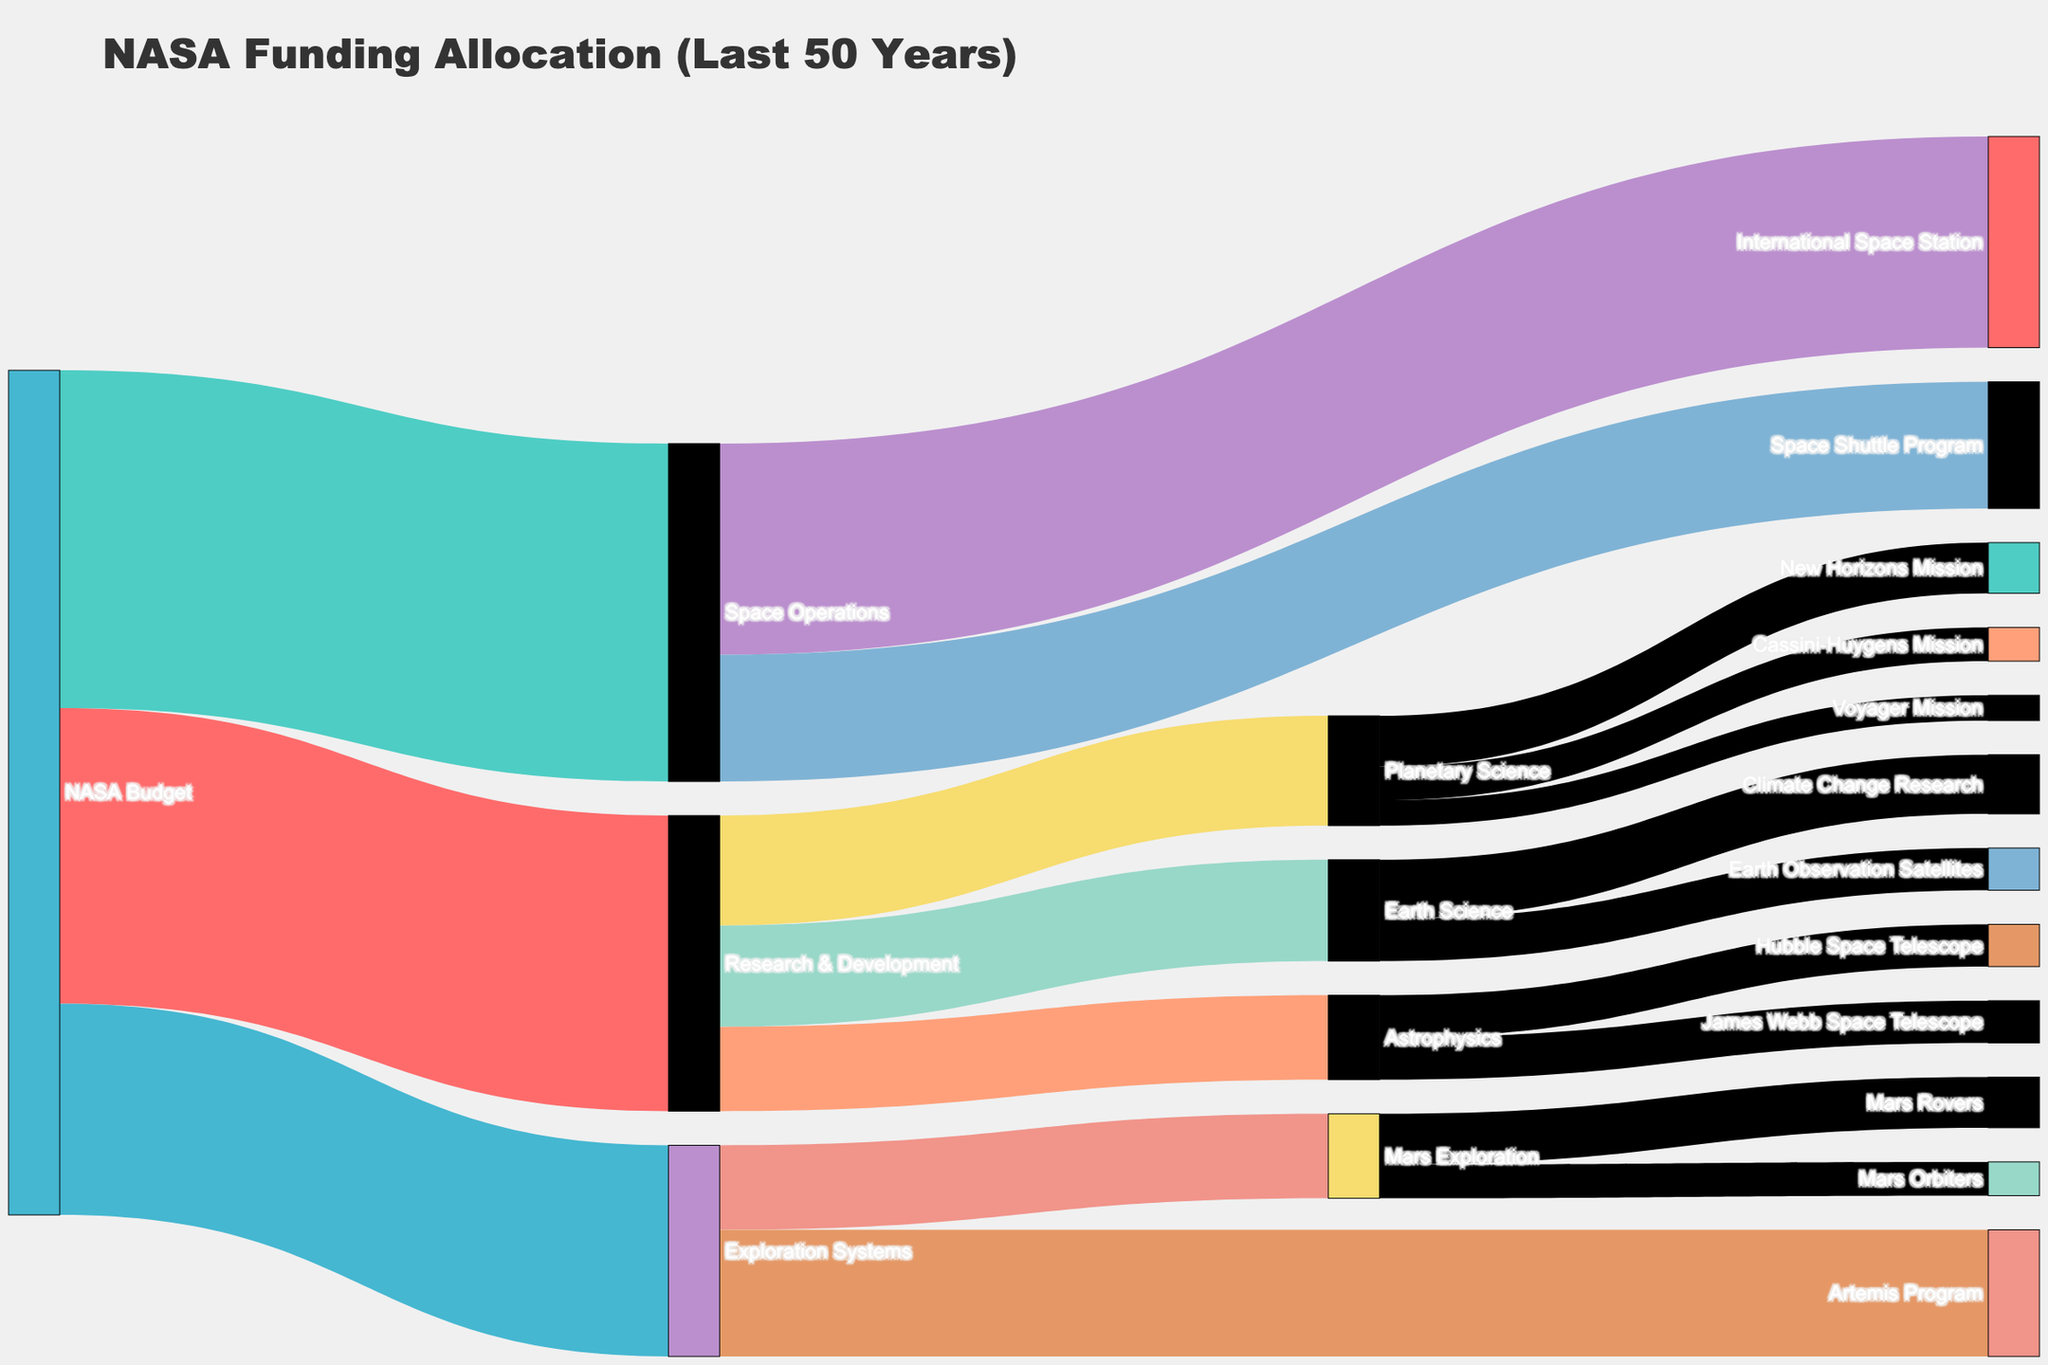What's the title of the figure? The title of the figure is typically displayed at the top and provides a summary of what the figure is about.
Answer: NASA Funding Allocation (Last 50 Years) How much funding was allocated to Astrophysics from Research & Development? By following the link from Research & Development to Astrophysics in the Sankey diagram, you can see the value associated with this link.
Answer: 10 Which target received the most funding from NASA Budget? By examining the width of the flows from NASA Budget to its targets, you can determine which target has the widest flow. Space Operations appears to have the largest value.
Answer: Space Operations What's the combined funding allocation to Planetary Science and Earth Science from Research & Development? Add the values from Research & Development to both Planetary Science (13) and Earth Science (12). Sum these two values.
Answer: 25 How much total funding was allocated to the International Space Station? Check the width of the flow from Space Operations to the International Space Station and note the value indicated.
Answer: 25 Which has a larger allocation, Mars Rovers or Mars Orbiters? Compare the values noted on the flows from Mars Exploration to Mars Rovers (6) and Mars Orbiters (4).
Answer: Mars Rovers What is the funding difference between the Space Shuttle Program and the Artemis Program? Find the values for Space Shuttle Program (15) and Artemis Program (15). Calculate the absolute difference between these values.
Answer: 0 How much funding in total was spent on "Mars Exploration"? Sum the values associated with the flows from Mars Exploration, Mars Rovers (6) and Mars Orbiters (4).
Answer: 10 Which project received equal funding from Research & Development and Space Operations? Identify the individual projects and check if any of them have equal value flows from Research & Development and Space Operations. None of the projects have equal values from these two sources.
Answer: None 